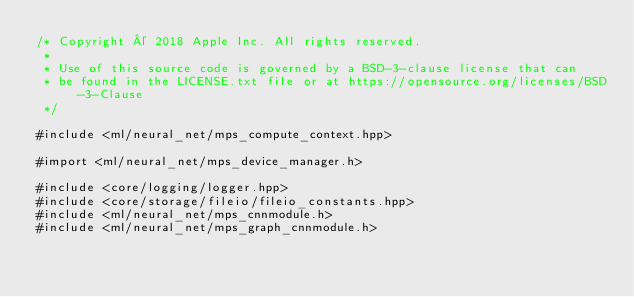<code> <loc_0><loc_0><loc_500><loc_500><_ObjectiveC_>/* Copyright © 2018 Apple Inc. All rights reserved.
 *
 * Use of this source code is governed by a BSD-3-clause license that can
 * be found in the LICENSE.txt file or at https://opensource.org/licenses/BSD-3-Clause
 */

#include <ml/neural_net/mps_compute_context.hpp>

#import <ml/neural_net/mps_device_manager.h>

#include <core/logging/logger.hpp>
#include <core/storage/fileio/fileio_constants.hpp>
#include <ml/neural_net/mps_cnnmodule.h>
#include <ml/neural_net/mps_graph_cnnmodule.h></code> 